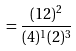Convert formula to latex. <formula><loc_0><loc_0><loc_500><loc_500>= \frac { ( 1 2 ) ^ { 2 } } { ( 4 ) ^ { 1 } ( 2 ) ^ { 3 } }</formula> 